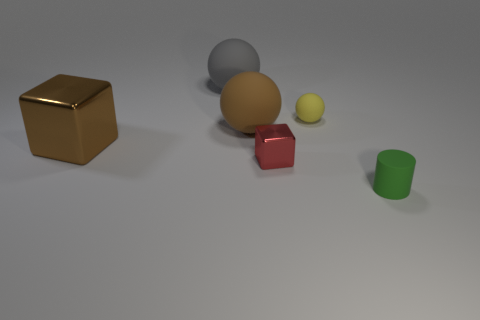Add 2 small green cylinders. How many objects exist? 8 Subtract all cylinders. How many objects are left? 5 Add 6 purple metal objects. How many purple metal objects exist? 6 Subtract 1 brown balls. How many objects are left? 5 Subtract all tiny matte cylinders. Subtract all big brown balls. How many objects are left? 4 Add 6 tiny matte cylinders. How many tiny matte cylinders are left? 7 